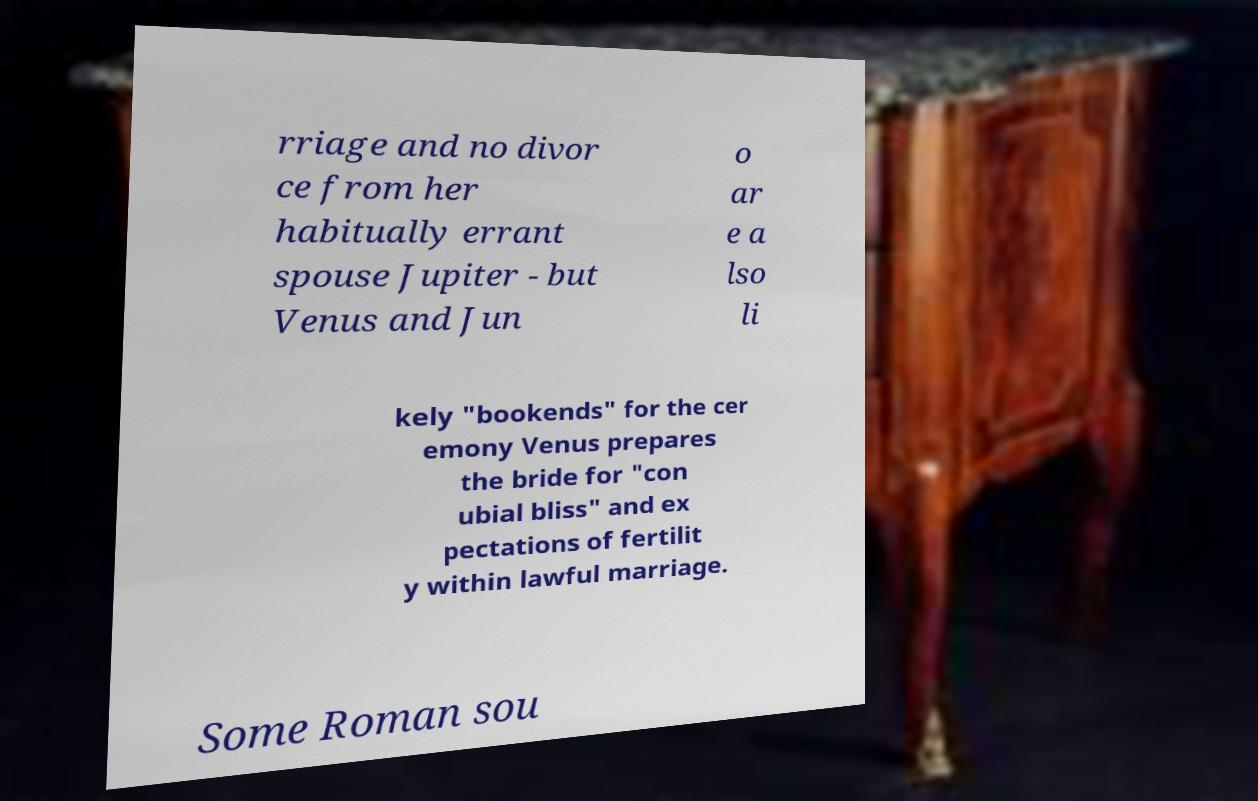I need the written content from this picture converted into text. Can you do that? rriage and no divor ce from her habitually errant spouse Jupiter - but Venus and Jun o ar e a lso li kely "bookends" for the cer emony Venus prepares the bride for "con ubial bliss" and ex pectations of fertilit y within lawful marriage. Some Roman sou 